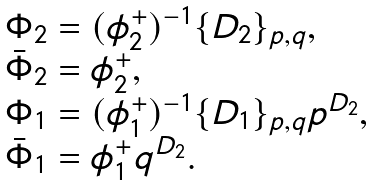<formula> <loc_0><loc_0><loc_500><loc_500>\begin{array} { l } \Phi _ { 2 } = ( \phi _ { 2 } ^ { + } ) ^ { - 1 } \{ D _ { 2 } \} _ { p , q } , \\ \bar { \Phi } _ { 2 } = \phi _ { 2 } ^ { + } , \\ \Phi _ { 1 } = ( \phi _ { 1 } ^ { + } ) ^ { - 1 } \{ D _ { 1 } \} _ { p , q } p ^ { D _ { 2 } } , \\ \bar { \Phi } _ { 1 } = \phi _ { 1 } ^ { + } q ^ { D _ { 2 } } . \end{array}</formula> 